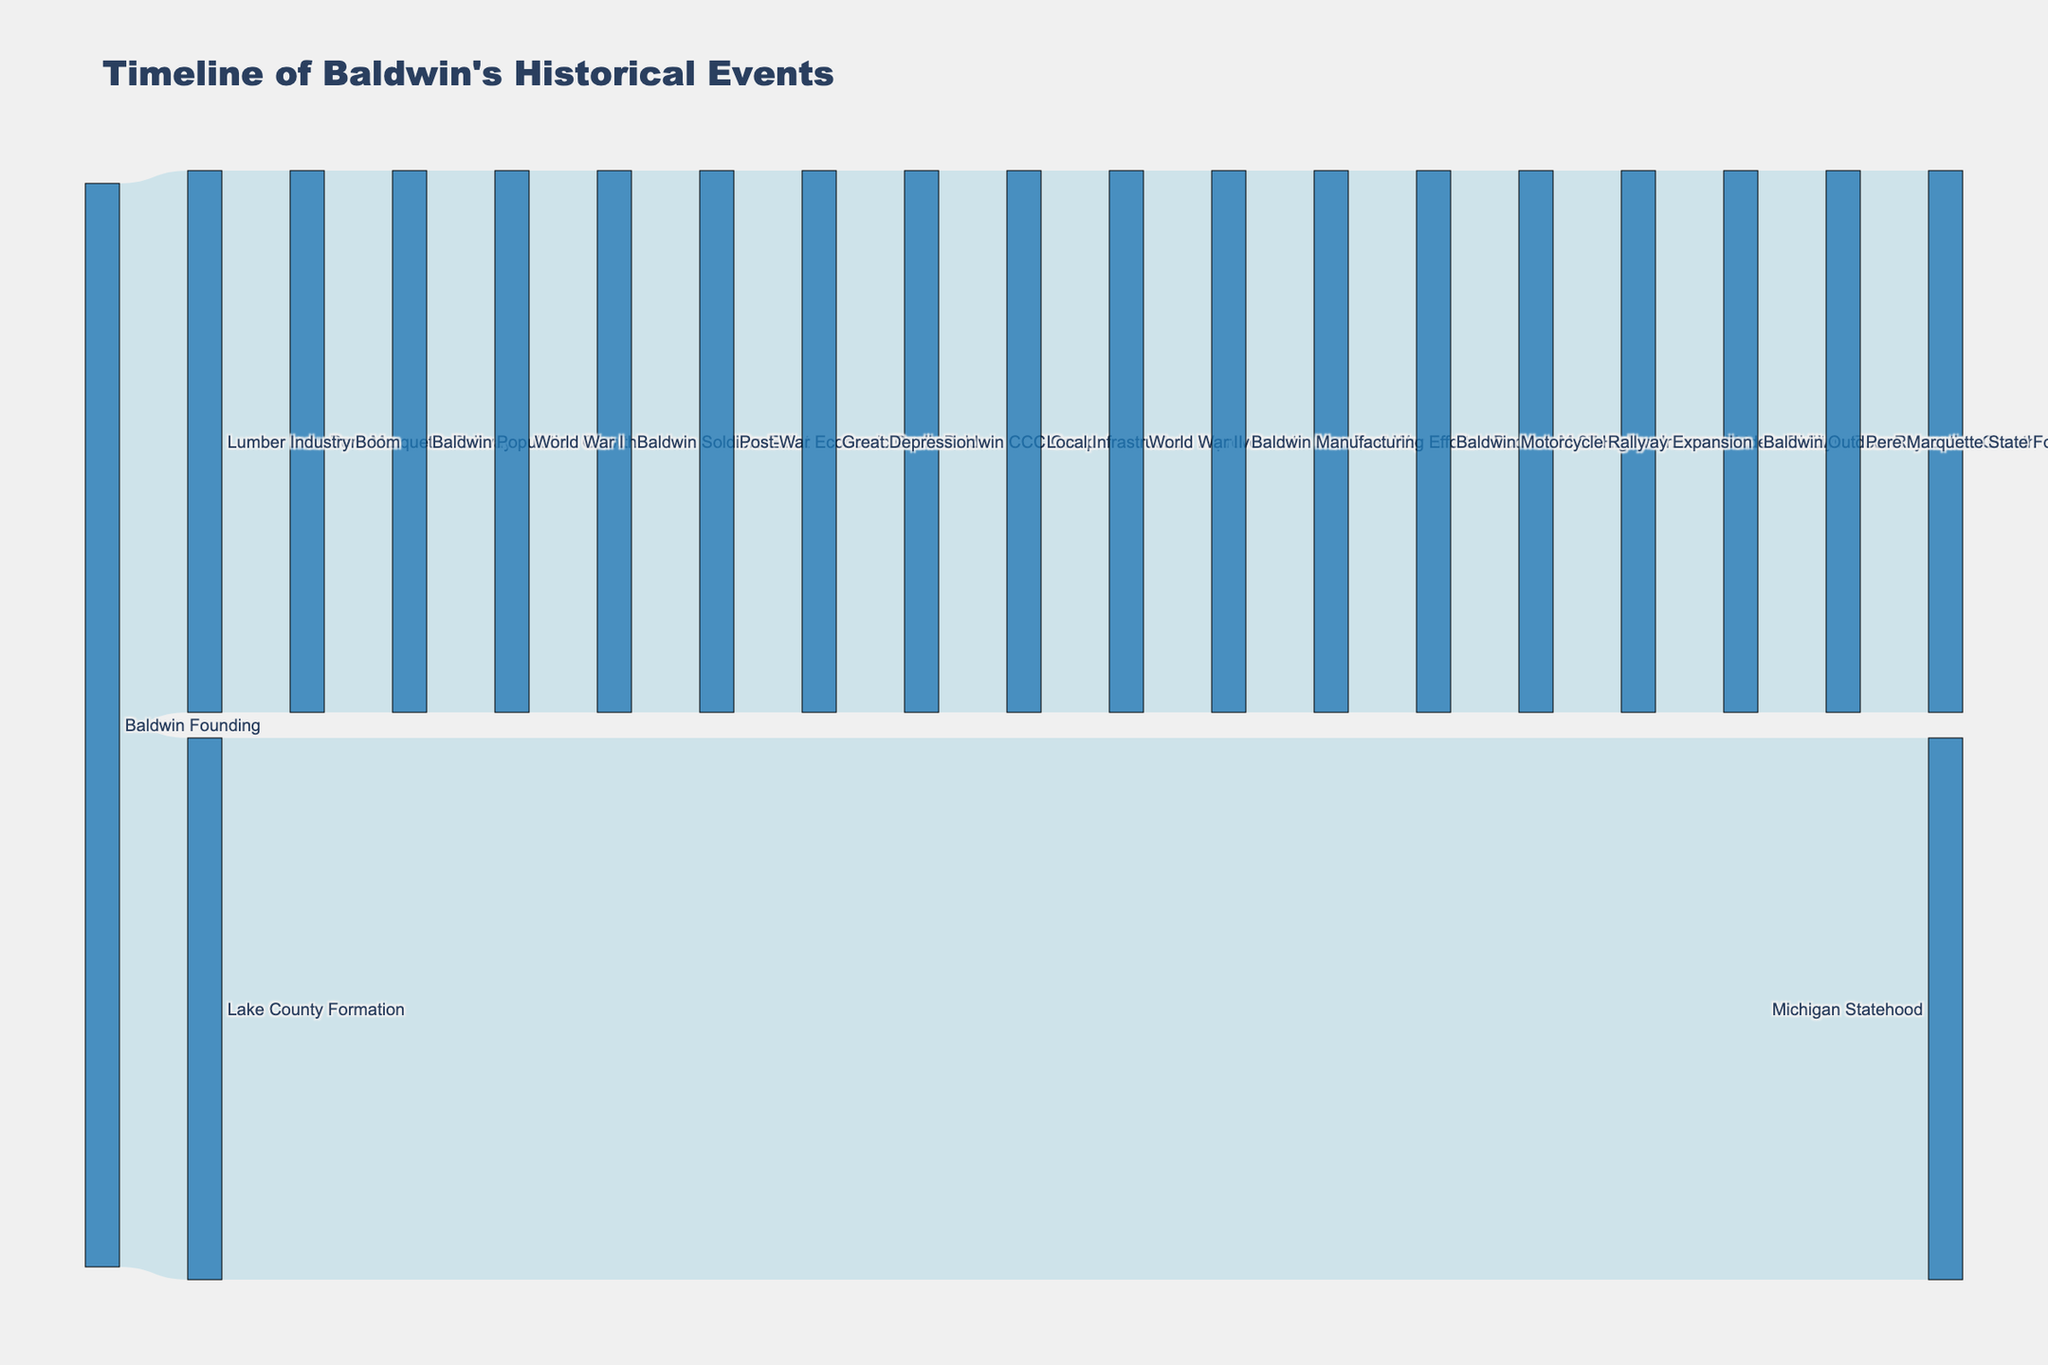What is the title of the Sankey diagram? The title is usually displayed at the top of the diagram. Look for the large, bold text that represents the main subject of the visualization.
Answer: Timeline of Baldwin's Historical Events What event directly follows the Baldwin Founding in the timeline? Trace the flow from the Baldwin Founding node to see which node is connected directly. The first target node linked directly from Baldwin Founding is the event that follows.
Answer: Lake County Formation How many events are connected to the Great Depression? Observe the Great Depression node and count both incoming and outgoing links to determine the number of events connected to it.
Answer: 2 What historical event is associated with Baldwin Soldiers Enlist? Identify the node labeled Baldwin Soldiers Enlist and see which source node it is connected to, indicating the associated historical event.
Answer: World War I Which event has the highest number of subsequent events linked to it? Examine all nodes and count the number of outgoing links for each node. The node with the most outgoing links is the one with the highest number of subsequent events.
Answer: Baldwin Population Growth What is the logical sequence that leads from Baldwin Founding to the Modern Baldwin Economy? Follow the path starting from Baldwin Founding and trace through each connected node step-by-step until you reach the Modern Baldwin Economy node. This involves identifying each intermediary event.
Answer: Baldwin Founding → Lumber Industry Boom → Pere Marquette Railway → Baldwin Population Growth → World War I → Baldwin Soldiers Enlist → Post-War Economic Decline → Great Depression → Baldwin CCC Camp → Local Infrastructure Improvement → World War II → Baldwin Manufacturing Efforts → Post-War Tourism Boom → Baldwin Motorcycle Rally → M-37 Highway Expansion → Increased Accessibility → Baldwin Outdoor Recreation Growth → Pere Marquette State Forest Expansion → Modern Baldwin Economy Which event is linked to the beginning of the Lumber Industry Boom? Locate the Lumber Industry Boom node and check its source node to find which event marks its beginning.
Answer: Baldwin Founding Compare the direct impacts of World War I and World War II on Baldwin. Identify the nodes directly linked to World War I and World War II, then compare the subsequent events triggered by each of these wars on Baldwin to see which one had more significant or varied impacts.
Answer: World War I impacted Baldwin Soldiers Enlist, while World War II impacted Baldwin Manufacturing Efforts Which event contributed to both local and national historical contexts? Look for an event linked to both local and broader (state or national) events. The nodes and links connecting these contexts will show the contributions.
Answer: Local Infrastructure Improvement (linked to World War II) Describe how the Great Depression affected Baldwin's development. Trace the path starting from the Great Depression node to see the consequent nodes and events it led to in Baldwin, giving a clear picture of its impact.
Answer: The Great Depression led to Baldwin CCC Camp and subsequently to Local Infrastructure Improvement 